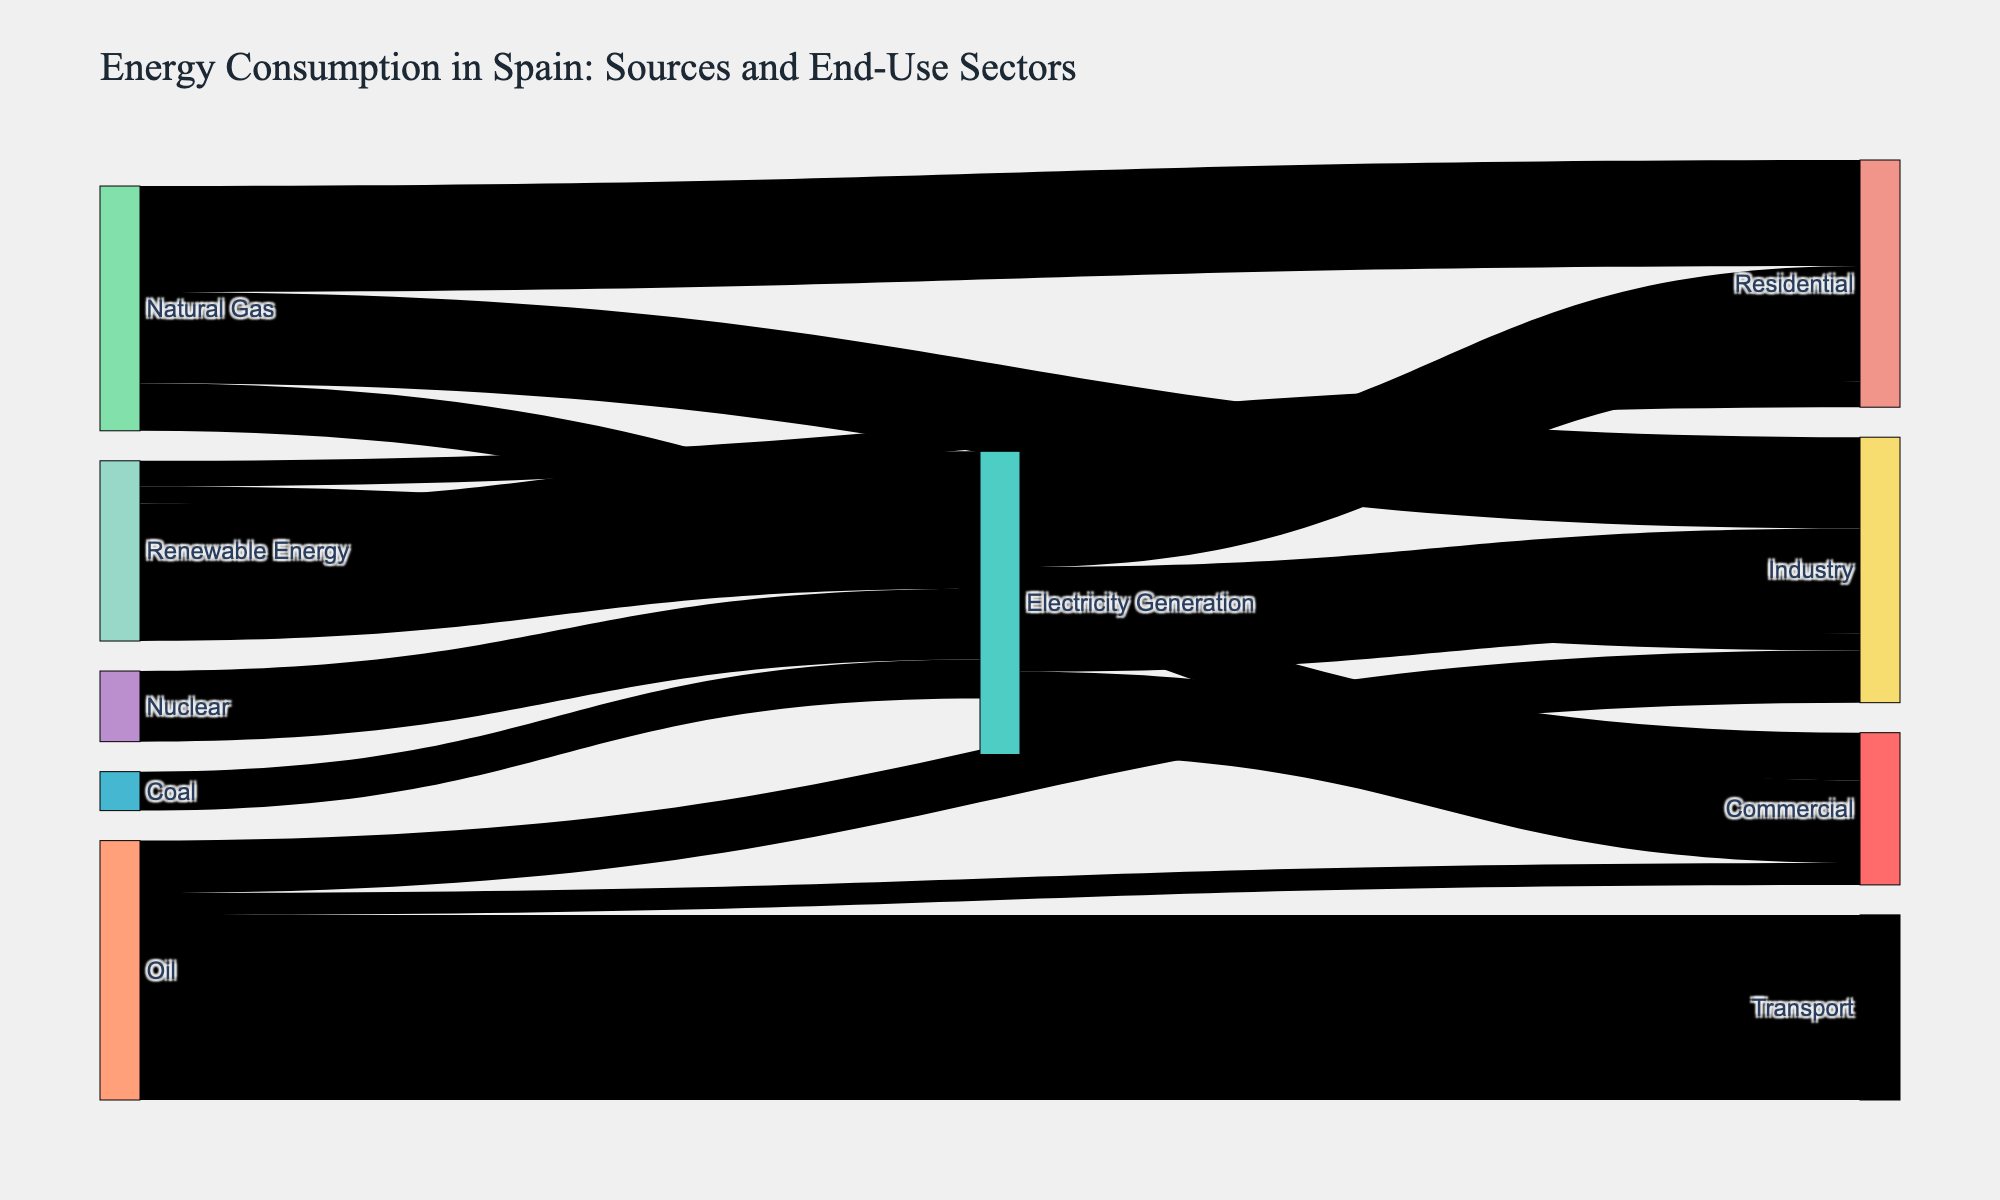What is the primary source of energy for the transport sector? By examining the Sankey diagram, we observe that the largest link to the "Transport" sector comes from "Oil" with a value of 15.2.
Answer: Oil Which sector uses the most energy from renewable sources? From the Sankey diagram, the largest link associated with "Renewable Energy" is directed towards "Electricity Generation" with a value of 11.3.
Answer: Electricity Generation What is the total energy consumption in the residential sector? The residential sector consumes energy from "Natural Gas" (8.7), "Electricity Generation" (9.5), and "Renewable Energy" (2.1). Adding these values gives us 8.7 + 9.5 + 2.1 = 20.3.
Answer: 20.3 How does the energy consumption of the commercial sector from electricity compare to natural gas? In the Sankey diagram, "Electricity Generation" to "Commercial" is 6.8, while "Natural Gas" to "Commercial" is 3.9. Comparing these values, electricity consumption (6.8) is greater than natural gas (3.9).
Answer: Electricity is greater than Natural Gas Which sector utilizes the least amount of coal energy? From the Sankey diagram, coal energy is only linked to "Electricity Generation" with a value of 3.2.
Answer: Electricity Generation What is the combined energy consumption of the industry sector from oil and natural gas? The industry sector consumes energy from "Oil" (4.3) and "Natural Gas" (7.5). Adding these values gives 4.3 + 7.5 = 11.8.
Answer: 11.8 Which energy source is utilized by the most number of sectors? By observing the Sankey diagram, it is evident that "Natural Gas" is used by three sectors: Residential, Industry, and Commercial.
Answer: Natural Gas 